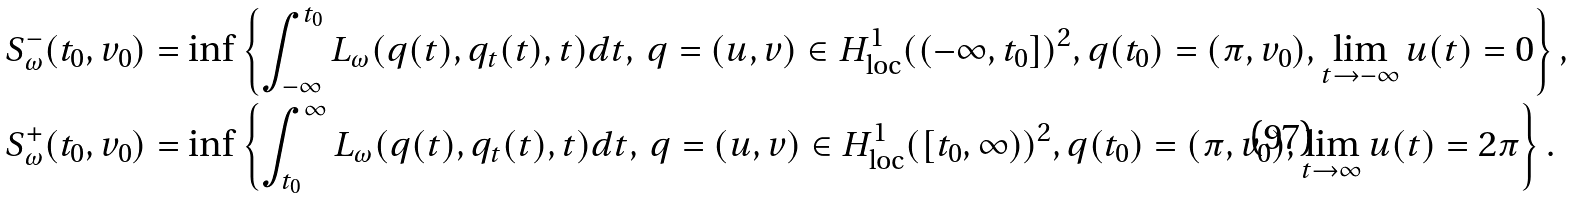<formula> <loc_0><loc_0><loc_500><loc_500>S ^ { - } _ { \omega } ( t _ { 0 } , v _ { 0 } ) & = \inf \left \{ \int _ { - \infty } ^ { t _ { 0 } } L _ { \omega } ( q ( t ) , q _ { t } ( t ) , t ) d t , \, q = ( u , v ) \in H ^ { 1 } _ { \text {loc} } ( ( - \infty , t _ { 0 } ] ) ^ { 2 } , q ( t _ { 0 } ) = ( \pi , v _ { 0 } ) , \lim _ { t \rightarrow - \infty } u ( t ) = 0 \right \} , \\ S ^ { + } _ { \omega } ( t _ { 0 } , v _ { 0 } ) & = \inf \left \{ \int _ { t _ { 0 } } ^ { \infty } L _ { \omega } ( q ( t ) , q _ { t } ( t ) , t ) d t , \, q = ( u , v ) \in H ^ { 1 } _ { \text {loc} } ( [ t _ { 0 } , \infty ) ) ^ { 2 } , q ( t _ { 0 } ) = ( \pi , v _ { 0 } ) , \lim _ { t \rightarrow \infty } u ( t ) = 2 \pi \right \} .</formula> 